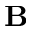<formula> <loc_0><loc_0><loc_500><loc_500>B</formula> 